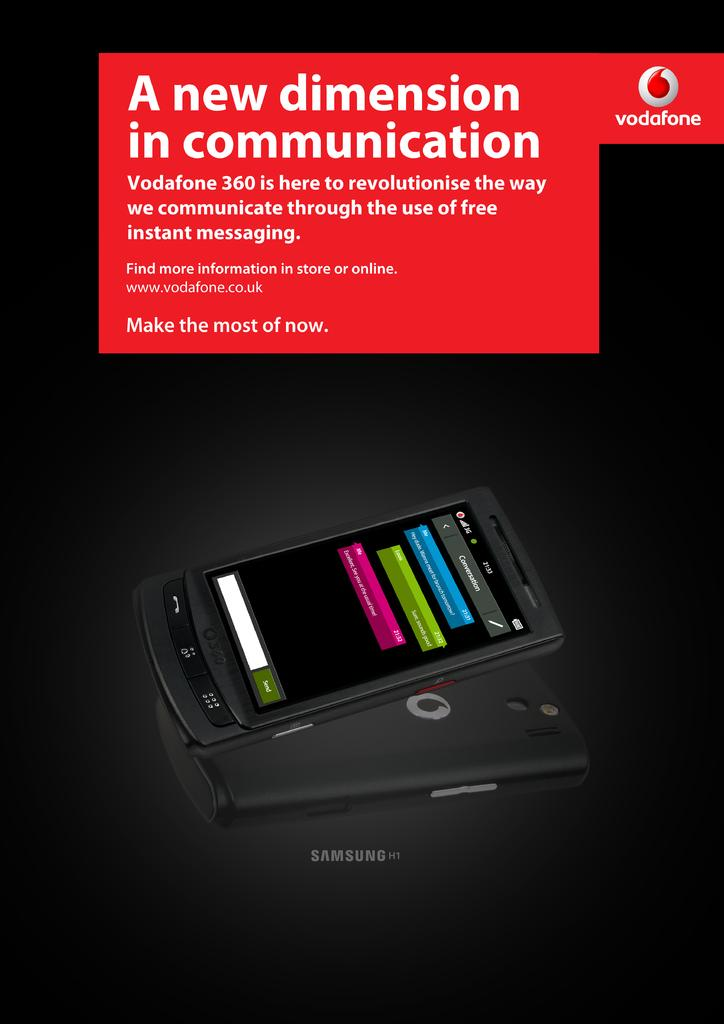<image>
Present a compact description of the photo's key features. Cell phone advertisement that is made by Samsung 